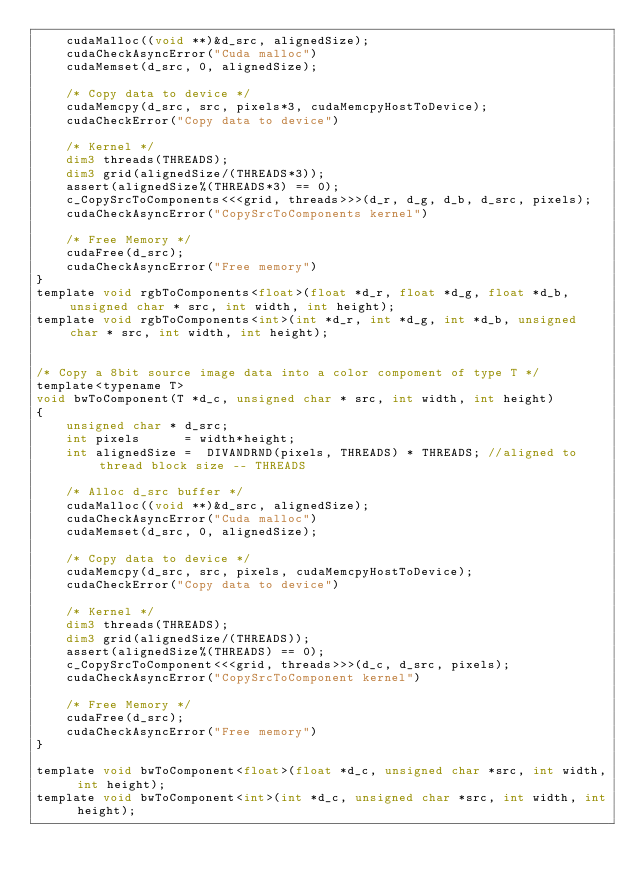<code> <loc_0><loc_0><loc_500><loc_500><_Cuda_>    cudaMalloc((void **)&d_src, alignedSize);
    cudaCheckAsyncError("Cuda malloc")
    cudaMemset(d_src, 0, alignedSize);

    /* Copy data to device */
    cudaMemcpy(d_src, src, pixels*3, cudaMemcpyHostToDevice);
    cudaCheckError("Copy data to device")

    /* Kernel */
    dim3 threads(THREADS);
    dim3 grid(alignedSize/(THREADS*3));
    assert(alignedSize%(THREADS*3) == 0);
    c_CopySrcToComponents<<<grid, threads>>>(d_r, d_g, d_b, d_src, pixels);
    cudaCheckAsyncError("CopySrcToComponents kernel")

    /* Free Memory */
    cudaFree(d_src);
    cudaCheckAsyncError("Free memory")
}
template void rgbToComponents<float>(float *d_r, float *d_g, float *d_b, unsigned char * src, int width, int height);
template void rgbToComponents<int>(int *d_r, int *d_g, int *d_b, unsigned char * src, int width, int height);


/* Copy a 8bit source image data into a color compoment of type T */
template<typename T>
void bwToComponent(T *d_c, unsigned char * src, int width, int height)
{
    unsigned char * d_src;
    int pixels      = width*height;
    int alignedSize =  DIVANDRND(pixels, THREADS) * THREADS; //aligned to thread block size -- THREADS

    /* Alloc d_src buffer */
    cudaMalloc((void **)&d_src, alignedSize);
    cudaCheckAsyncError("Cuda malloc")
    cudaMemset(d_src, 0, alignedSize);

    /* Copy data to device */
    cudaMemcpy(d_src, src, pixels, cudaMemcpyHostToDevice);
    cudaCheckError("Copy data to device")

    /* Kernel */
    dim3 threads(THREADS);
    dim3 grid(alignedSize/(THREADS));
    assert(alignedSize%(THREADS) == 0);
    c_CopySrcToComponent<<<grid, threads>>>(d_c, d_src, pixels);
    cudaCheckAsyncError("CopySrcToComponent kernel")

    /* Free Memory */
    cudaFree(d_src);
    cudaCheckAsyncError("Free memory")
}

template void bwToComponent<float>(float *d_c, unsigned char *src, int width, int height);
template void bwToComponent<int>(int *d_c, unsigned char *src, int width, int height);
</code> 